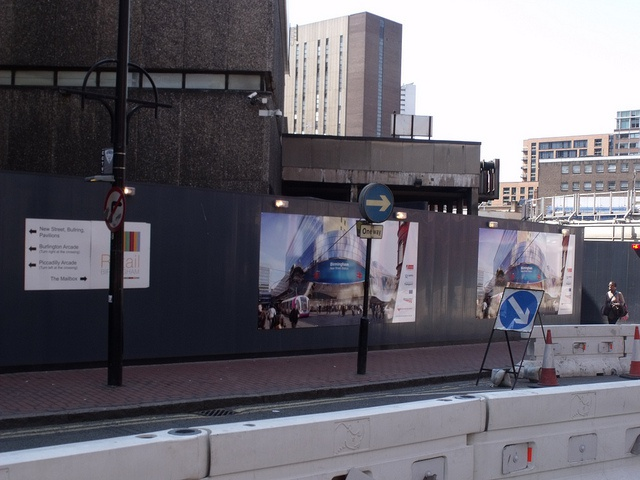Describe the objects in this image and their specific colors. I can see people in black, gray, purple, and maroon tones, people in black and gray tones, people in black and gray tones, people in black, gray, and purple tones, and people in black and gray tones in this image. 